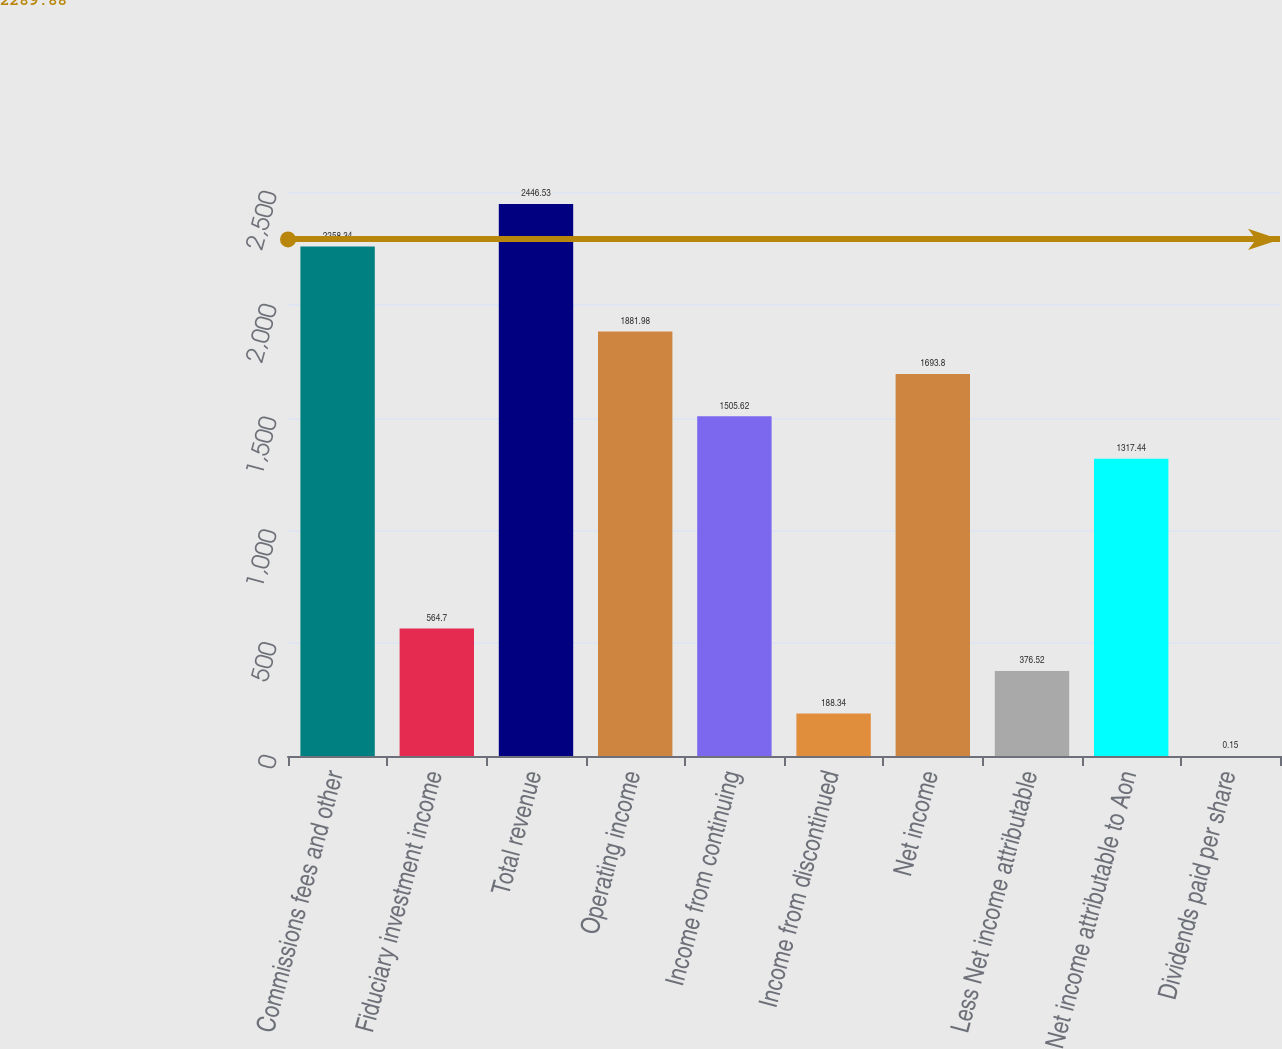Convert chart. <chart><loc_0><loc_0><loc_500><loc_500><bar_chart><fcel>Commissions fees and other<fcel>Fiduciary investment income<fcel>Total revenue<fcel>Operating income<fcel>Income from continuing<fcel>Income from discontinued<fcel>Net income<fcel>Less Net income attributable<fcel>Net income attributable to Aon<fcel>Dividends paid per share<nl><fcel>2258.34<fcel>564.7<fcel>2446.53<fcel>1881.98<fcel>1505.62<fcel>188.34<fcel>1693.8<fcel>376.52<fcel>1317.44<fcel>0.15<nl></chart> 